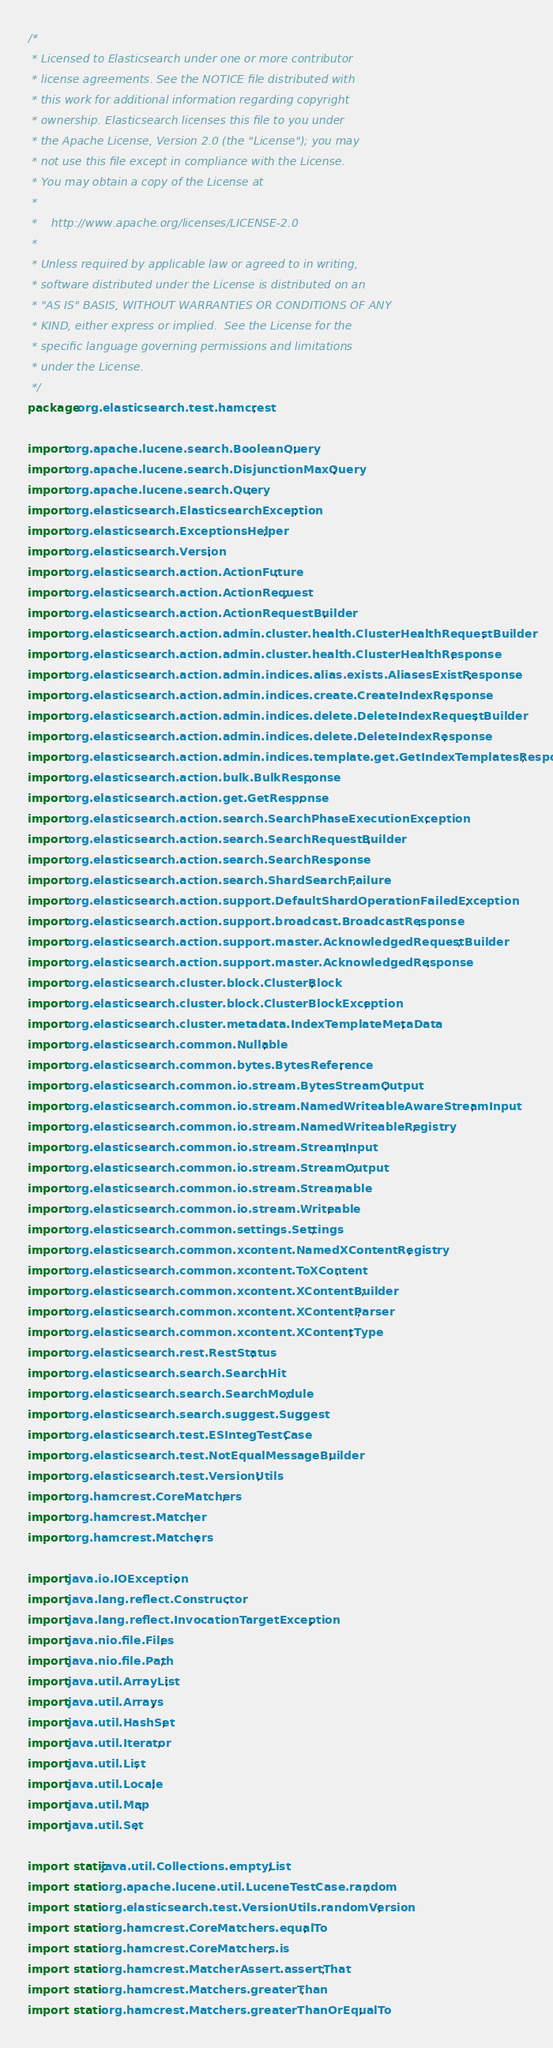<code> <loc_0><loc_0><loc_500><loc_500><_Java_>/*
 * Licensed to Elasticsearch under one or more contributor
 * license agreements. See the NOTICE file distributed with
 * this work for additional information regarding copyright
 * ownership. Elasticsearch licenses this file to you under
 * the Apache License, Version 2.0 (the "License"); you may
 * not use this file except in compliance with the License.
 * You may obtain a copy of the License at
 *
 *    http://www.apache.org/licenses/LICENSE-2.0
 *
 * Unless required by applicable law or agreed to in writing,
 * software distributed under the License is distributed on an
 * "AS IS" BASIS, WITHOUT WARRANTIES OR CONDITIONS OF ANY
 * KIND, either express or implied.  See the License for the
 * specific language governing permissions and limitations
 * under the License.
 */
package org.elasticsearch.test.hamcrest;

import org.apache.lucene.search.BooleanQuery;
import org.apache.lucene.search.DisjunctionMaxQuery;
import org.apache.lucene.search.Query;
import org.elasticsearch.ElasticsearchException;
import org.elasticsearch.ExceptionsHelper;
import org.elasticsearch.Version;
import org.elasticsearch.action.ActionFuture;
import org.elasticsearch.action.ActionRequest;
import org.elasticsearch.action.ActionRequestBuilder;
import org.elasticsearch.action.admin.cluster.health.ClusterHealthRequestBuilder;
import org.elasticsearch.action.admin.cluster.health.ClusterHealthResponse;
import org.elasticsearch.action.admin.indices.alias.exists.AliasesExistResponse;
import org.elasticsearch.action.admin.indices.create.CreateIndexResponse;
import org.elasticsearch.action.admin.indices.delete.DeleteIndexRequestBuilder;
import org.elasticsearch.action.admin.indices.delete.DeleteIndexResponse;
import org.elasticsearch.action.admin.indices.template.get.GetIndexTemplatesResponse;
import org.elasticsearch.action.bulk.BulkResponse;
import org.elasticsearch.action.get.GetResponse;
import org.elasticsearch.action.search.SearchPhaseExecutionException;
import org.elasticsearch.action.search.SearchRequestBuilder;
import org.elasticsearch.action.search.SearchResponse;
import org.elasticsearch.action.search.ShardSearchFailure;
import org.elasticsearch.action.support.DefaultShardOperationFailedException;
import org.elasticsearch.action.support.broadcast.BroadcastResponse;
import org.elasticsearch.action.support.master.AcknowledgedRequestBuilder;
import org.elasticsearch.action.support.master.AcknowledgedResponse;
import org.elasticsearch.cluster.block.ClusterBlock;
import org.elasticsearch.cluster.block.ClusterBlockException;
import org.elasticsearch.cluster.metadata.IndexTemplateMetaData;
import org.elasticsearch.common.Nullable;
import org.elasticsearch.common.bytes.BytesReference;
import org.elasticsearch.common.io.stream.BytesStreamOutput;
import org.elasticsearch.common.io.stream.NamedWriteableAwareStreamInput;
import org.elasticsearch.common.io.stream.NamedWriteableRegistry;
import org.elasticsearch.common.io.stream.StreamInput;
import org.elasticsearch.common.io.stream.StreamOutput;
import org.elasticsearch.common.io.stream.Streamable;
import org.elasticsearch.common.io.stream.Writeable;
import org.elasticsearch.common.settings.Settings;
import org.elasticsearch.common.xcontent.NamedXContentRegistry;
import org.elasticsearch.common.xcontent.ToXContent;
import org.elasticsearch.common.xcontent.XContentBuilder;
import org.elasticsearch.common.xcontent.XContentParser;
import org.elasticsearch.common.xcontent.XContentType;
import org.elasticsearch.rest.RestStatus;
import org.elasticsearch.search.SearchHit;
import org.elasticsearch.search.SearchModule;
import org.elasticsearch.search.suggest.Suggest;
import org.elasticsearch.test.ESIntegTestCase;
import org.elasticsearch.test.NotEqualMessageBuilder;
import org.elasticsearch.test.VersionUtils;
import org.hamcrest.CoreMatchers;
import org.hamcrest.Matcher;
import org.hamcrest.Matchers;

import java.io.IOException;
import java.lang.reflect.Constructor;
import java.lang.reflect.InvocationTargetException;
import java.nio.file.Files;
import java.nio.file.Path;
import java.util.ArrayList;
import java.util.Arrays;
import java.util.HashSet;
import java.util.Iterator;
import java.util.List;
import java.util.Locale;
import java.util.Map;
import java.util.Set;

import static java.util.Collections.emptyList;
import static org.apache.lucene.util.LuceneTestCase.random;
import static org.elasticsearch.test.VersionUtils.randomVersion;
import static org.hamcrest.CoreMatchers.equalTo;
import static org.hamcrest.CoreMatchers.is;
import static org.hamcrest.MatcherAssert.assertThat;
import static org.hamcrest.Matchers.greaterThan;
import static org.hamcrest.Matchers.greaterThanOrEqualTo;</code> 